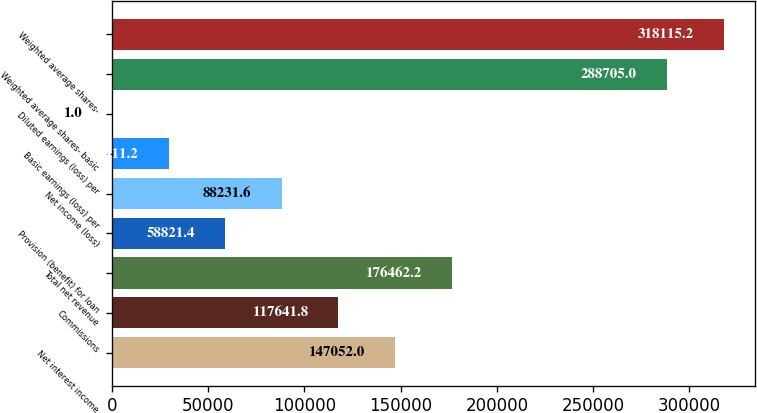<chart> <loc_0><loc_0><loc_500><loc_500><bar_chart><fcel>Net interest income<fcel>Commissions<fcel>Total net revenue<fcel>Provision (benefit) for loan<fcel>Net income (loss)<fcel>Basic earnings (loss) per<fcel>Diluted earnings (loss) per<fcel>Weighted average shares- basic<fcel>Weighted average shares-<nl><fcel>147052<fcel>117642<fcel>176462<fcel>58821.4<fcel>88231.6<fcel>29411.2<fcel>1<fcel>288705<fcel>318115<nl></chart> 